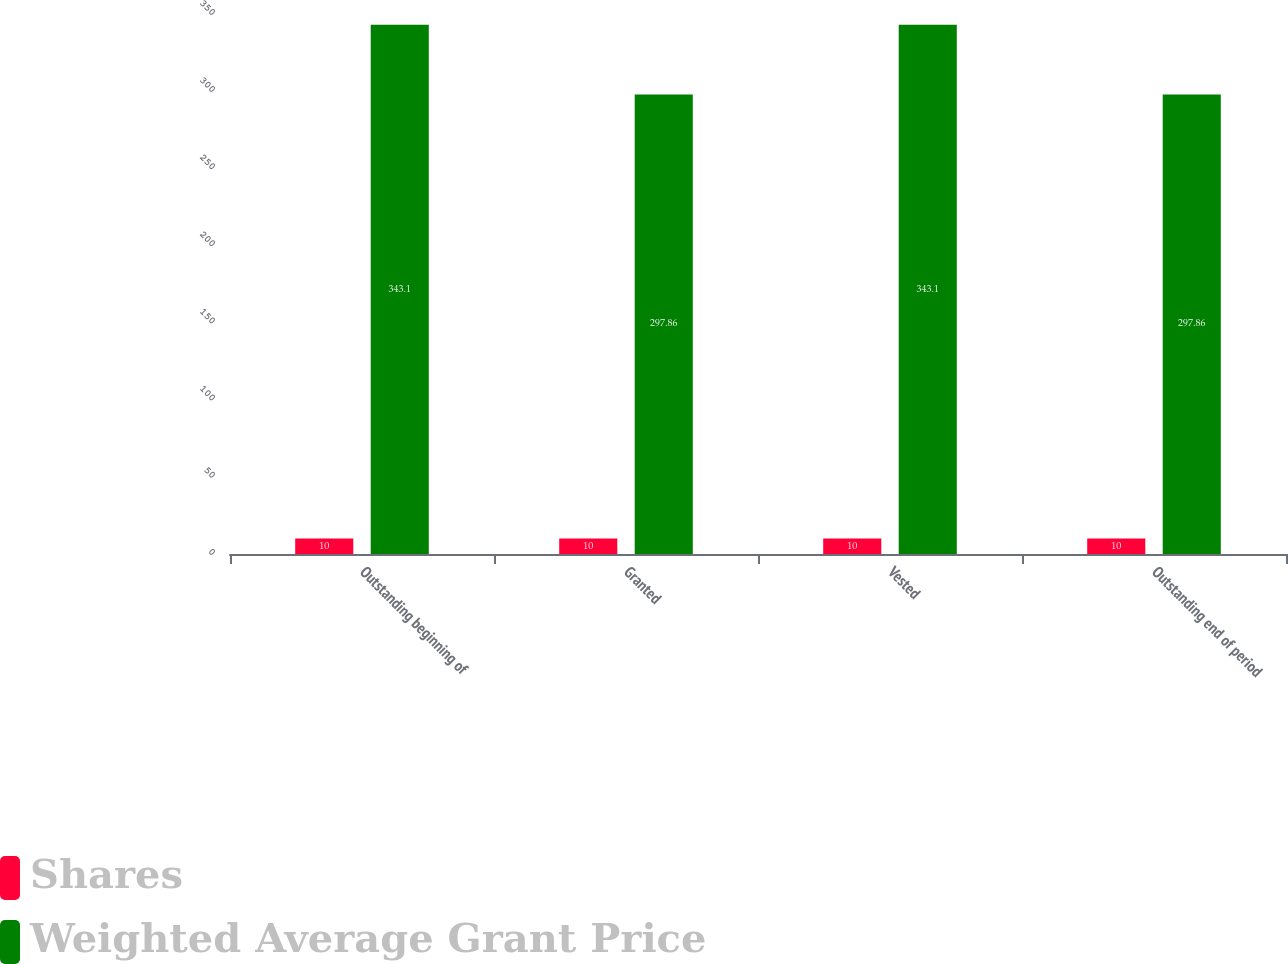<chart> <loc_0><loc_0><loc_500><loc_500><stacked_bar_chart><ecel><fcel>Outstanding beginning of<fcel>Granted<fcel>Vested<fcel>Outstanding end of period<nl><fcel>Shares<fcel>10<fcel>10<fcel>10<fcel>10<nl><fcel>Weighted Average Grant Price<fcel>343.1<fcel>297.86<fcel>343.1<fcel>297.86<nl></chart> 